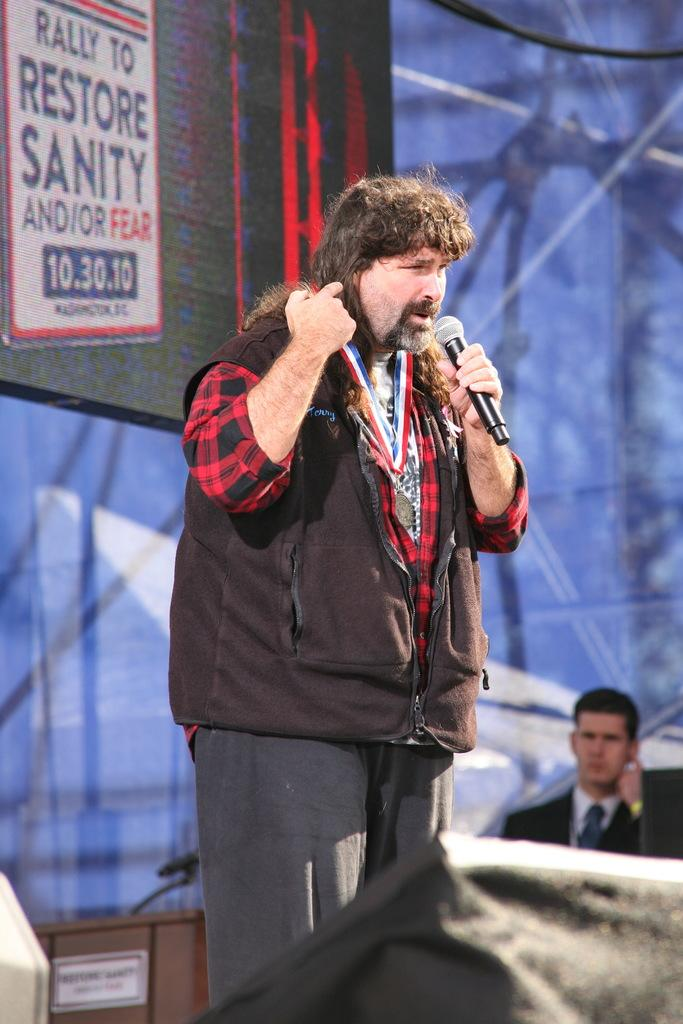What can be seen in the image? There is a person in the image. What is the person wearing? The person is wearing a black color jacket. What is the person doing in the image? The person is standing and holding a microphone in his hand. What is visible in the background of the image? There is a black color sheet in the background of the image. What type of brick is being used to build the furniture in the image? There is no brick or furniture present in the image. How many muscles can be seen on the person's arm in the image? The image does not show the person's arm or muscles, so it cannot be determined from the image. 